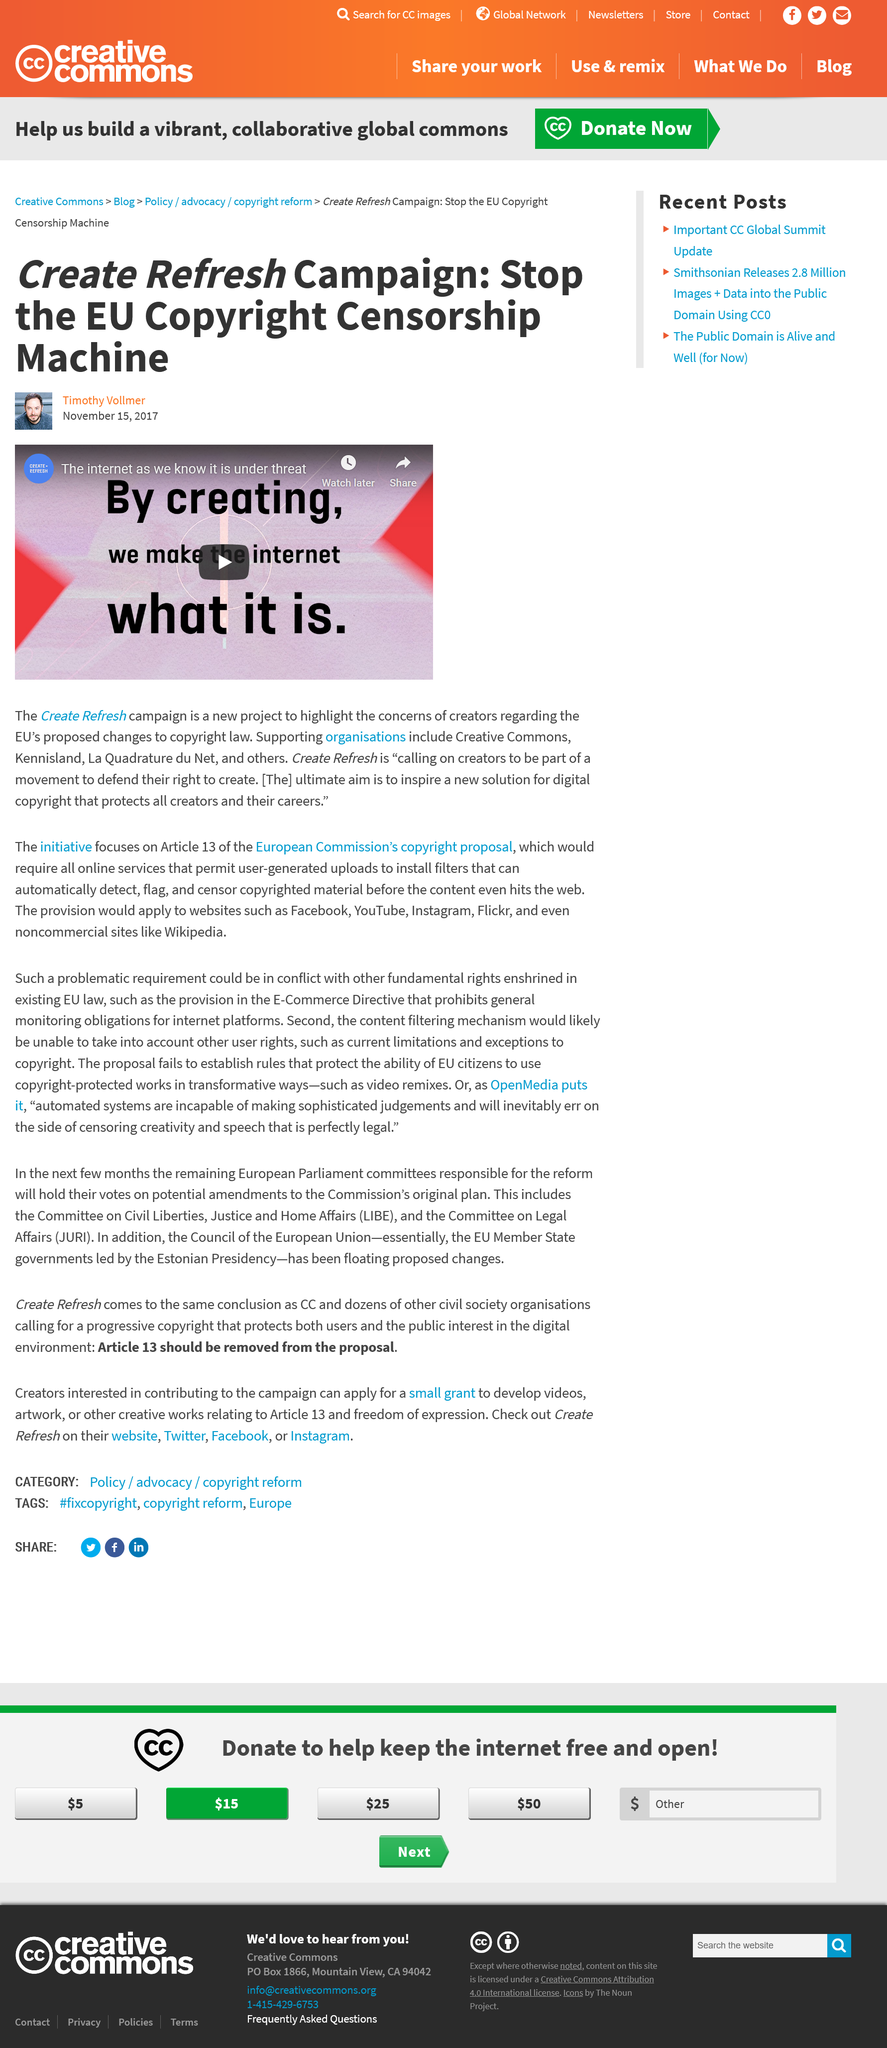Draw attention to some important aspects in this diagram. The "Create Refresh" campaign, as stated by Timothy Vollmer, aims to promote the development of a digital copyright system that safeguards the interests of all creators and preserves their professional success. The "Create Refresh" campaign aims to raise awareness about the concerns of creators regarding the copyright rules of the European Union. Three organisations supporting the "Create Refresh" campaign are Creative Commons, Kennisland, and La Quadrature du Net. 